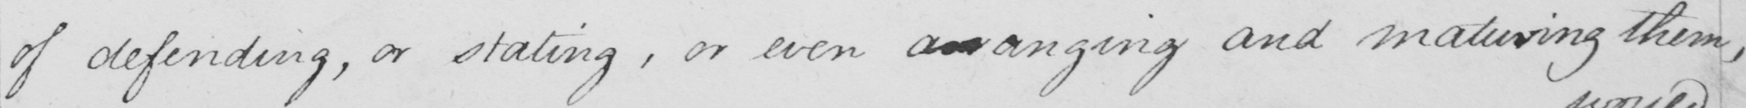Can you tell me what this handwritten text says? of defending , or stating , or even an arguing and maturing them , 